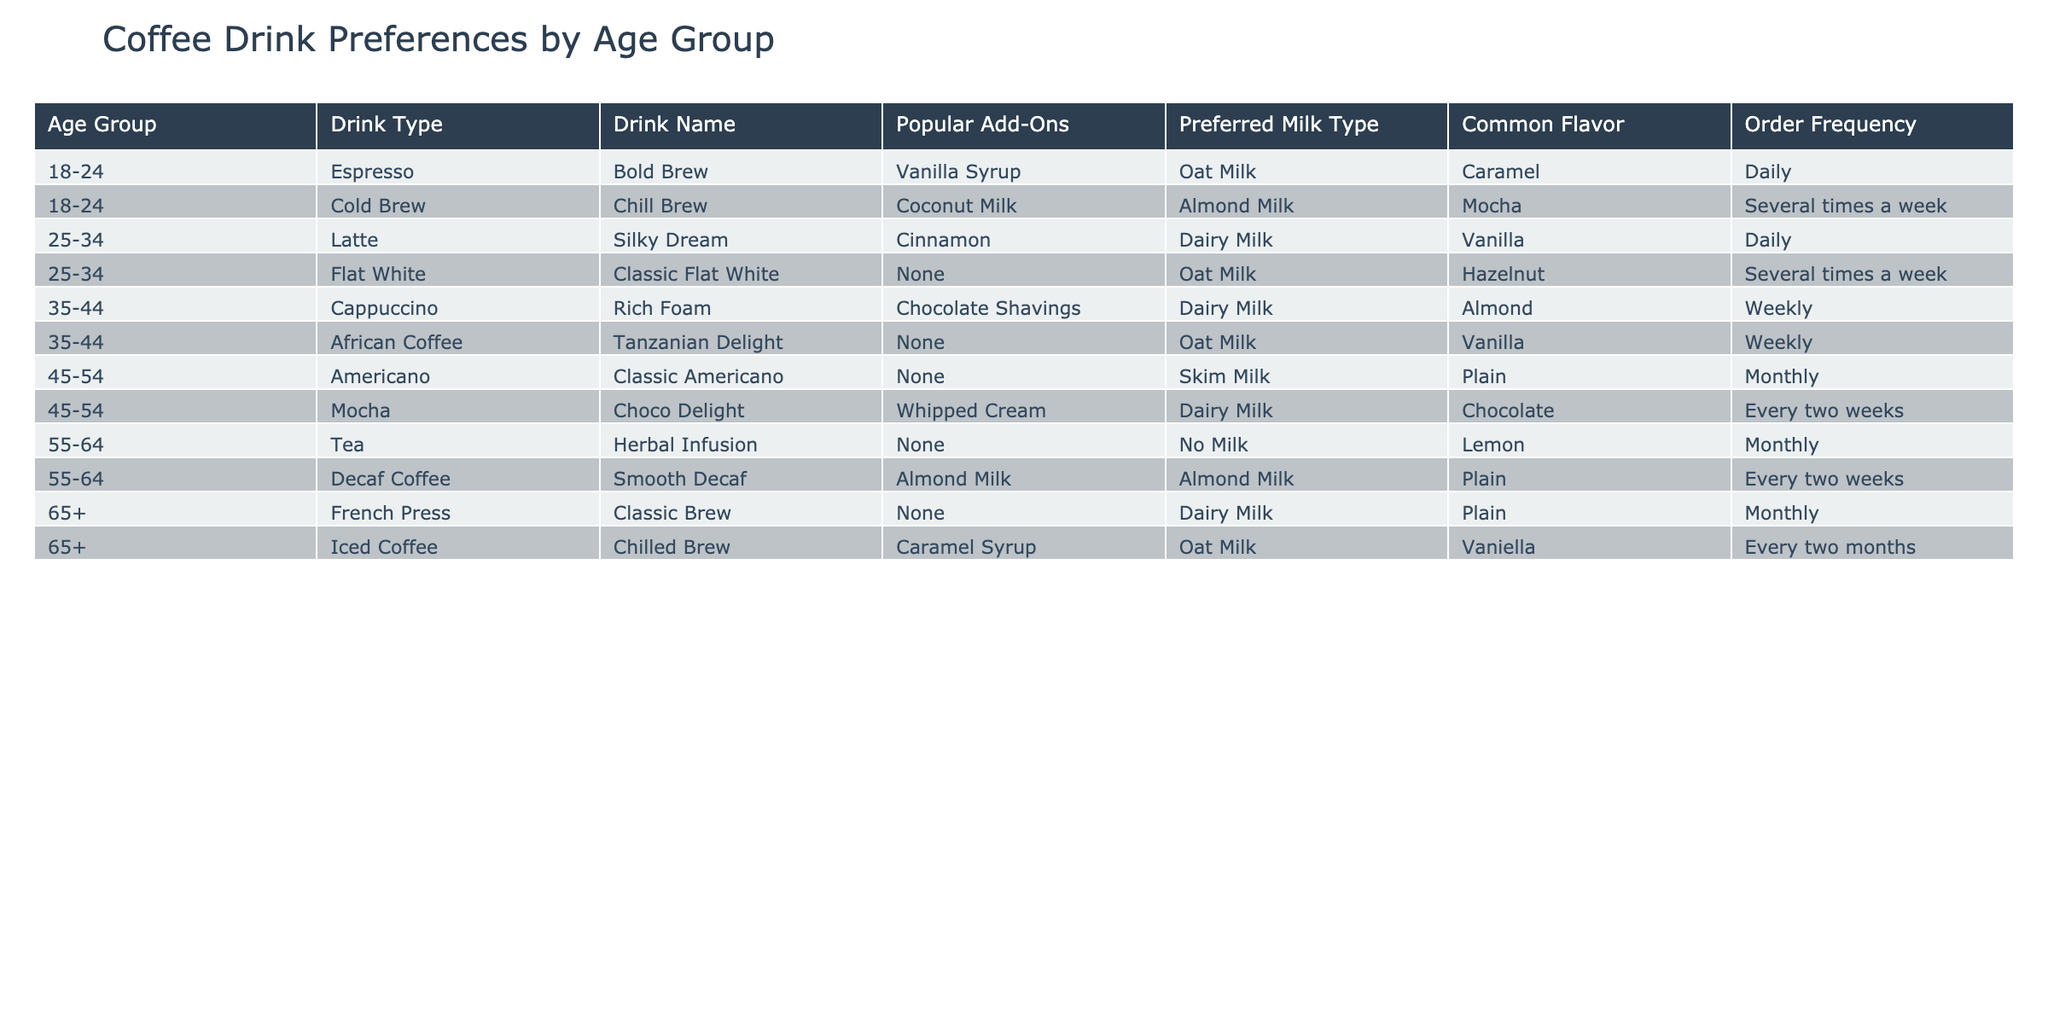What is the most popular drink type among the 18-24 age group? By examining the rows related to the 18-24 age group, the drink types listed are Espresso and Cold Brew. Since both have high order frequencies, we note that Espresso is mentioned with daily frequency, which suggests it is preferred more than Cold Brew, which is mentioned as several times a week.
Answer: Espresso Which drink type is favored by the 45-54 age group? In the table, there are two drink types listed under the 45-54 age group: Americano and Mocha. Each has a different frequency, but Mocha, which is described as having a higher frequency of every two weeks compared to Americano, which is monthly, suggests Mocha is favored.
Answer: Mocha Do customers aged 55-64 prefer tea or coffee? Looking at the rows for the 55-64 age group, the table shows one entry for Tea (Herbal Infusion) and one for Decaf Coffee. Since both are listed, but only tea has been mentioned along with a specific add-on (none), we can conclude that their single preference is Tea, as it is the only type listed for this age.
Answer: Yes, tea What is the order frequency for Flat White? The entry for Flat White states it is ordered several times a week. This is explicitly mentioned in the table under the 25-34 age group. Therefore, the answer comes directly from the order frequency noted for this drink.
Answer: Several times a week Among the 35-44 age group, what are the drink types offered with add-ons? In the entries for the 35-44 age group, Cappuccino comes with Chocolate Shavings, while African Coffee has no add-ons. Thus, Cappuccino is the only drink type that offers add-ons based on what is provided in the table.
Answer: Cappuccino What is the common flavor for the Iced Coffee in the 65+ age group? The entry for Iced Coffee shows that its common flavor is Vanilla. This detail can be found directly in the row pertaining to the Iced Coffee under the 65+ age group.
Answer: Vanilla Which milk type is preferred for the Latte in the 25-34 age group? From the table, the preferred milk type listed for Latte is Dairy Milk. This value can be directly found in the table under the corresponding row for the age group that orders this drink.
Answer: Dairy Milk How many different drinks does the 25-34 age group prefer according to the data? There are two drink types mentioned in the table under the 25-34 age group: Latte and Flat White. Since these are two distinct entries, we see the preference for two different drinks.
Answer: Two Which drink type has the highest order frequency for customers aged 35-44? Examining the entries for the 35-44 age group yields two drinks: Cappuccino ordered weekly and African Coffee ordered weekly as well. However, since both are mentioned as weekly, they share the highest frequency according to the data provided.
Answer: Both have the same order frequency (weekly) 